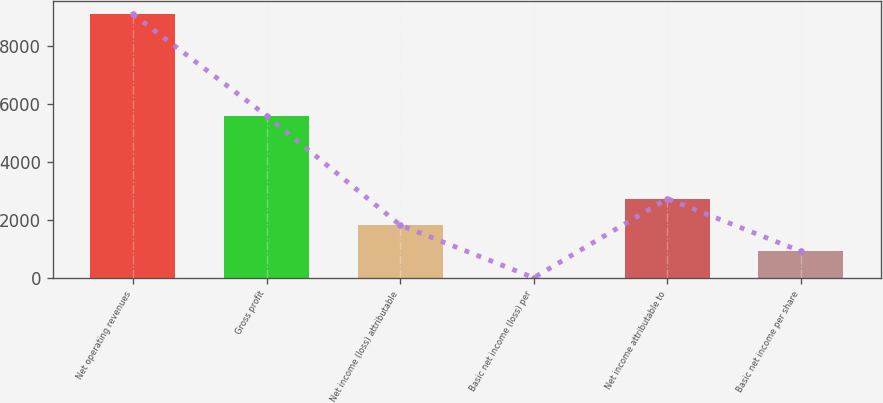Convert chart. <chart><loc_0><loc_0><loc_500><loc_500><bar_chart><fcel>Net operating revenues<fcel>Gross profit<fcel>Net income (loss) attributable<fcel>Basic net income (loss) per<fcel>Net income attributable to<fcel>Basic net income per share<nl><fcel>9118<fcel>5605<fcel>1823.82<fcel>0.28<fcel>2735.59<fcel>912.05<nl></chart> 